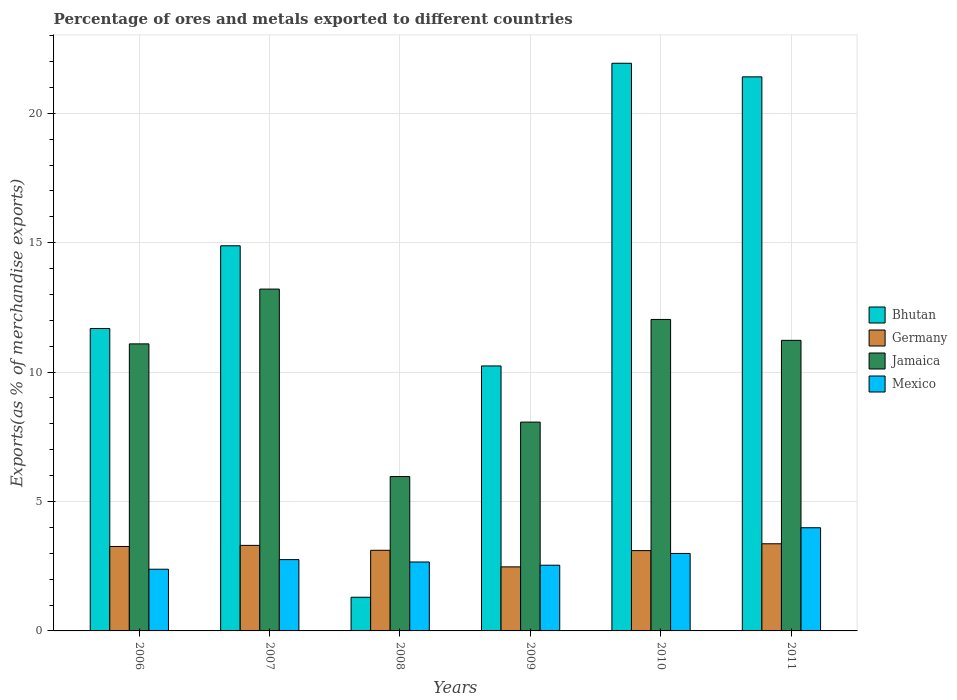How many different coloured bars are there?
Your answer should be very brief. 4. Are the number of bars per tick equal to the number of legend labels?
Your answer should be compact. Yes. How many bars are there on the 4th tick from the left?
Offer a terse response. 4. How many bars are there on the 4th tick from the right?
Your answer should be very brief. 4. What is the label of the 2nd group of bars from the left?
Provide a short and direct response. 2007. In how many cases, is the number of bars for a given year not equal to the number of legend labels?
Offer a very short reply. 0. What is the percentage of exports to different countries in Mexico in 2006?
Your answer should be compact. 2.38. Across all years, what is the maximum percentage of exports to different countries in Bhutan?
Offer a terse response. 21.93. Across all years, what is the minimum percentage of exports to different countries in Bhutan?
Give a very brief answer. 1.3. In which year was the percentage of exports to different countries in Mexico minimum?
Give a very brief answer. 2006. What is the total percentage of exports to different countries in Jamaica in the graph?
Offer a terse response. 61.59. What is the difference between the percentage of exports to different countries in Bhutan in 2006 and that in 2008?
Provide a succinct answer. 10.38. What is the difference between the percentage of exports to different countries in Bhutan in 2008 and the percentage of exports to different countries in Jamaica in 2009?
Your answer should be compact. -6.77. What is the average percentage of exports to different countries in Jamaica per year?
Ensure brevity in your answer.  10.27. In the year 2011, what is the difference between the percentage of exports to different countries in Jamaica and percentage of exports to different countries in Mexico?
Your answer should be compact. 7.24. In how many years, is the percentage of exports to different countries in Germany greater than 7 %?
Offer a very short reply. 0. What is the ratio of the percentage of exports to different countries in Mexico in 2007 to that in 2010?
Your response must be concise. 0.92. Is the difference between the percentage of exports to different countries in Jamaica in 2006 and 2011 greater than the difference between the percentage of exports to different countries in Mexico in 2006 and 2011?
Provide a short and direct response. Yes. What is the difference between the highest and the second highest percentage of exports to different countries in Mexico?
Give a very brief answer. 0.99. What is the difference between the highest and the lowest percentage of exports to different countries in Jamaica?
Keep it short and to the point. 7.24. In how many years, is the percentage of exports to different countries in Germany greater than the average percentage of exports to different countries in Germany taken over all years?
Your answer should be compact. 4. What does the 1st bar from the left in 2006 represents?
Ensure brevity in your answer.  Bhutan. What does the 4th bar from the right in 2008 represents?
Keep it short and to the point. Bhutan. How many years are there in the graph?
Make the answer very short. 6. What is the difference between two consecutive major ticks on the Y-axis?
Make the answer very short. 5. Are the values on the major ticks of Y-axis written in scientific E-notation?
Your response must be concise. No. Does the graph contain any zero values?
Your answer should be very brief. No. Does the graph contain grids?
Make the answer very short. Yes. How are the legend labels stacked?
Provide a succinct answer. Vertical. What is the title of the graph?
Provide a succinct answer. Percentage of ores and metals exported to different countries. What is the label or title of the Y-axis?
Offer a very short reply. Exports(as % of merchandise exports). What is the Exports(as % of merchandise exports) in Bhutan in 2006?
Give a very brief answer. 11.68. What is the Exports(as % of merchandise exports) in Germany in 2006?
Provide a succinct answer. 3.26. What is the Exports(as % of merchandise exports) in Jamaica in 2006?
Offer a very short reply. 11.09. What is the Exports(as % of merchandise exports) of Mexico in 2006?
Offer a very short reply. 2.38. What is the Exports(as % of merchandise exports) in Bhutan in 2007?
Keep it short and to the point. 14.88. What is the Exports(as % of merchandise exports) of Germany in 2007?
Give a very brief answer. 3.3. What is the Exports(as % of merchandise exports) in Jamaica in 2007?
Provide a short and direct response. 13.21. What is the Exports(as % of merchandise exports) of Mexico in 2007?
Your answer should be compact. 2.76. What is the Exports(as % of merchandise exports) in Bhutan in 2008?
Offer a very short reply. 1.3. What is the Exports(as % of merchandise exports) in Germany in 2008?
Make the answer very short. 3.12. What is the Exports(as % of merchandise exports) of Jamaica in 2008?
Ensure brevity in your answer.  5.96. What is the Exports(as % of merchandise exports) in Mexico in 2008?
Keep it short and to the point. 2.66. What is the Exports(as % of merchandise exports) in Bhutan in 2009?
Give a very brief answer. 10.24. What is the Exports(as % of merchandise exports) of Germany in 2009?
Offer a terse response. 2.48. What is the Exports(as % of merchandise exports) of Jamaica in 2009?
Make the answer very short. 8.07. What is the Exports(as % of merchandise exports) of Mexico in 2009?
Keep it short and to the point. 2.54. What is the Exports(as % of merchandise exports) of Bhutan in 2010?
Ensure brevity in your answer.  21.93. What is the Exports(as % of merchandise exports) of Germany in 2010?
Offer a very short reply. 3.1. What is the Exports(as % of merchandise exports) of Jamaica in 2010?
Your answer should be very brief. 12.03. What is the Exports(as % of merchandise exports) of Mexico in 2010?
Make the answer very short. 2.99. What is the Exports(as % of merchandise exports) of Bhutan in 2011?
Your answer should be compact. 21.41. What is the Exports(as % of merchandise exports) of Germany in 2011?
Make the answer very short. 3.37. What is the Exports(as % of merchandise exports) of Jamaica in 2011?
Ensure brevity in your answer.  11.23. What is the Exports(as % of merchandise exports) in Mexico in 2011?
Offer a very short reply. 3.99. Across all years, what is the maximum Exports(as % of merchandise exports) in Bhutan?
Your answer should be compact. 21.93. Across all years, what is the maximum Exports(as % of merchandise exports) of Germany?
Keep it short and to the point. 3.37. Across all years, what is the maximum Exports(as % of merchandise exports) of Jamaica?
Offer a terse response. 13.21. Across all years, what is the maximum Exports(as % of merchandise exports) of Mexico?
Provide a short and direct response. 3.99. Across all years, what is the minimum Exports(as % of merchandise exports) in Bhutan?
Your answer should be compact. 1.3. Across all years, what is the minimum Exports(as % of merchandise exports) in Germany?
Make the answer very short. 2.48. Across all years, what is the minimum Exports(as % of merchandise exports) in Jamaica?
Keep it short and to the point. 5.96. Across all years, what is the minimum Exports(as % of merchandise exports) in Mexico?
Keep it short and to the point. 2.38. What is the total Exports(as % of merchandise exports) in Bhutan in the graph?
Provide a short and direct response. 81.45. What is the total Exports(as % of merchandise exports) of Germany in the graph?
Make the answer very short. 18.63. What is the total Exports(as % of merchandise exports) of Jamaica in the graph?
Provide a short and direct response. 61.59. What is the total Exports(as % of merchandise exports) of Mexico in the graph?
Provide a succinct answer. 17.32. What is the difference between the Exports(as % of merchandise exports) in Bhutan in 2006 and that in 2007?
Give a very brief answer. -3.2. What is the difference between the Exports(as % of merchandise exports) of Germany in 2006 and that in 2007?
Give a very brief answer. -0.04. What is the difference between the Exports(as % of merchandise exports) in Jamaica in 2006 and that in 2007?
Keep it short and to the point. -2.12. What is the difference between the Exports(as % of merchandise exports) of Mexico in 2006 and that in 2007?
Offer a terse response. -0.37. What is the difference between the Exports(as % of merchandise exports) in Bhutan in 2006 and that in 2008?
Provide a short and direct response. 10.38. What is the difference between the Exports(as % of merchandise exports) in Germany in 2006 and that in 2008?
Your answer should be very brief. 0.15. What is the difference between the Exports(as % of merchandise exports) in Jamaica in 2006 and that in 2008?
Ensure brevity in your answer.  5.13. What is the difference between the Exports(as % of merchandise exports) of Mexico in 2006 and that in 2008?
Make the answer very short. -0.28. What is the difference between the Exports(as % of merchandise exports) of Bhutan in 2006 and that in 2009?
Your response must be concise. 1.45. What is the difference between the Exports(as % of merchandise exports) in Germany in 2006 and that in 2009?
Make the answer very short. 0.79. What is the difference between the Exports(as % of merchandise exports) in Jamaica in 2006 and that in 2009?
Provide a succinct answer. 3.02. What is the difference between the Exports(as % of merchandise exports) in Mexico in 2006 and that in 2009?
Make the answer very short. -0.16. What is the difference between the Exports(as % of merchandise exports) of Bhutan in 2006 and that in 2010?
Ensure brevity in your answer.  -10.25. What is the difference between the Exports(as % of merchandise exports) of Germany in 2006 and that in 2010?
Your response must be concise. 0.16. What is the difference between the Exports(as % of merchandise exports) in Jamaica in 2006 and that in 2010?
Offer a very short reply. -0.94. What is the difference between the Exports(as % of merchandise exports) of Mexico in 2006 and that in 2010?
Provide a short and direct response. -0.61. What is the difference between the Exports(as % of merchandise exports) of Bhutan in 2006 and that in 2011?
Make the answer very short. -9.73. What is the difference between the Exports(as % of merchandise exports) of Germany in 2006 and that in 2011?
Your response must be concise. -0.1. What is the difference between the Exports(as % of merchandise exports) of Jamaica in 2006 and that in 2011?
Your answer should be compact. -0.14. What is the difference between the Exports(as % of merchandise exports) in Mexico in 2006 and that in 2011?
Your response must be concise. -1.6. What is the difference between the Exports(as % of merchandise exports) of Bhutan in 2007 and that in 2008?
Provide a short and direct response. 13.58. What is the difference between the Exports(as % of merchandise exports) in Germany in 2007 and that in 2008?
Provide a succinct answer. 0.19. What is the difference between the Exports(as % of merchandise exports) in Jamaica in 2007 and that in 2008?
Your answer should be compact. 7.24. What is the difference between the Exports(as % of merchandise exports) in Mexico in 2007 and that in 2008?
Offer a terse response. 0.09. What is the difference between the Exports(as % of merchandise exports) of Bhutan in 2007 and that in 2009?
Provide a short and direct response. 4.64. What is the difference between the Exports(as % of merchandise exports) of Germany in 2007 and that in 2009?
Provide a succinct answer. 0.83. What is the difference between the Exports(as % of merchandise exports) in Jamaica in 2007 and that in 2009?
Ensure brevity in your answer.  5.14. What is the difference between the Exports(as % of merchandise exports) of Mexico in 2007 and that in 2009?
Keep it short and to the point. 0.22. What is the difference between the Exports(as % of merchandise exports) of Bhutan in 2007 and that in 2010?
Your response must be concise. -7.05. What is the difference between the Exports(as % of merchandise exports) in Germany in 2007 and that in 2010?
Ensure brevity in your answer.  0.2. What is the difference between the Exports(as % of merchandise exports) in Jamaica in 2007 and that in 2010?
Give a very brief answer. 1.17. What is the difference between the Exports(as % of merchandise exports) in Mexico in 2007 and that in 2010?
Provide a short and direct response. -0.24. What is the difference between the Exports(as % of merchandise exports) of Bhutan in 2007 and that in 2011?
Your answer should be very brief. -6.53. What is the difference between the Exports(as % of merchandise exports) of Germany in 2007 and that in 2011?
Keep it short and to the point. -0.06. What is the difference between the Exports(as % of merchandise exports) of Jamaica in 2007 and that in 2011?
Give a very brief answer. 1.98. What is the difference between the Exports(as % of merchandise exports) in Mexico in 2007 and that in 2011?
Your response must be concise. -1.23. What is the difference between the Exports(as % of merchandise exports) of Bhutan in 2008 and that in 2009?
Give a very brief answer. -8.94. What is the difference between the Exports(as % of merchandise exports) in Germany in 2008 and that in 2009?
Your response must be concise. 0.64. What is the difference between the Exports(as % of merchandise exports) of Jamaica in 2008 and that in 2009?
Provide a short and direct response. -2.1. What is the difference between the Exports(as % of merchandise exports) in Mexico in 2008 and that in 2009?
Make the answer very short. 0.12. What is the difference between the Exports(as % of merchandise exports) in Bhutan in 2008 and that in 2010?
Give a very brief answer. -20.63. What is the difference between the Exports(as % of merchandise exports) in Germany in 2008 and that in 2010?
Keep it short and to the point. 0.01. What is the difference between the Exports(as % of merchandise exports) of Jamaica in 2008 and that in 2010?
Ensure brevity in your answer.  -6.07. What is the difference between the Exports(as % of merchandise exports) of Mexico in 2008 and that in 2010?
Give a very brief answer. -0.33. What is the difference between the Exports(as % of merchandise exports) in Bhutan in 2008 and that in 2011?
Keep it short and to the point. -20.11. What is the difference between the Exports(as % of merchandise exports) in Germany in 2008 and that in 2011?
Your answer should be compact. -0.25. What is the difference between the Exports(as % of merchandise exports) in Jamaica in 2008 and that in 2011?
Your answer should be very brief. -5.26. What is the difference between the Exports(as % of merchandise exports) of Mexico in 2008 and that in 2011?
Provide a short and direct response. -1.32. What is the difference between the Exports(as % of merchandise exports) in Bhutan in 2009 and that in 2010?
Your answer should be very brief. -11.7. What is the difference between the Exports(as % of merchandise exports) of Germany in 2009 and that in 2010?
Your answer should be very brief. -0.63. What is the difference between the Exports(as % of merchandise exports) in Jamaica in 2009 and that in 2010?
Ensure brevity in your answer.  -3.97. What is the difference between the Exports(as % of merchandise exports) in Mexico in 2009 and that in 2010?
Give a very brief answer. -0.45. What is the difference between the Exports(as % of merchandise exports) in Bhutan in 2009 and that in 2011?
Your response must be concise. -11.17. What is the difference between the Exports(as % of merchandise exports) in Germany in 2009 and that in 2011?
Your answer should be compact. -0.89. What is the difference between the Exports(as % of merchandise exports) of Jamaica in 2009 and that in 2011?
Your answer should be compact. -3.16. What is the difference between the Exports(as % of merchandise exports) in Mexico in 2009 and that in 2011?
Your answer should be compact. -1.45. What is the difference between the Exports(as % of merchandise exports) in Bhutan in 2010 and that in 2011?
Give a very brief answer. 0.53. What is the difference between the Exports(as % of merchandise exports) in Germany in 2010 and that in 2011?
Ensure brevity in your answer.  -0.26. What is the difference between the Exports(as % of merchandise exports) in Jamaica in 2010 and that in 2011?
Offer a very short reply. 0.81. What is the difference between the Exports(as % of merchandise exports) of Mexico in 2010 and that in 2011?
Provide a short and direct response. -0.99. What is the difference between the Exports(as % of merchandise exports) of Bhutan in 2006 and the Exports(as % of merchandise exports) of Germany in 2007?
Your answer should be very brief. 8.38. What is the difference between the Exports(as % of merchandise exports) in Bhutan in 2006 and the Exports(as % of merchandise exports) in Jamaica in 2007?
Offer a very short reply. -1.52. What is the difference between the Exports(as % of merchandise exports) of Bhutan in 2006 and the Exports(as % of merchandise exports) of Mexico in 2007?
Make the answer very short. 8.93. What is the difference between the Exports(as % of merchandise exports) in Germany in 2006 and the Exports(as % of merchandise exports) in Jamaica in 2007?
Keep it short and to the point. -9.95. What is the difference between the Exports(as % of merchandise exports) in Germany in 2006 and the Exports(as % of merchandise exports) in Mexico in 2007?
Offer a very short reply. 0.51. What is the difference between the Exports(as % of merchandise exports) of Jamaica in 2006 and the Exports(as % of merchandise exports) of Mexico in 2007?
Your answer should be compact. 8.34. What is the difference between the Exports(as % of merchandise exports) in Bhutan in 2006 and the Exports(as % of merchandise exports) in Germany in 2008?
Your answer should be very brief. 8.57. What is the difference between the Exports(as % of merchandise exports) in Bhutan in 2006 and the Exports(as % of merchandise exports) in Jamaica in 2008?
Keep it short and to the point. 5.72. What is the difference between the Exports(as % of merchandise exports) in Bhutan in 2006 and the Exports(as % of merchandise exports) in Mexico in 2008?
Offer a terse response. 9.02. What is the difference between the Exports(as % of merchandise exports) of Germany in 2006 and the Exports(as % of merchandise exports) of Jamaica in 2008?
Provide a short and direct response. -2.7. What is the difference between the Exports(as % of merchandise exports) in Germany in 2006 and the Exports(as % of merchandise exports) in Mexico in 2008?
Your answer should be very brief. 0.6. What is the difference between the Exports(as % of merchandise exports) in Jamaica in 2006 and the Exports(as % of merchandise exports) in Mexico in 2008?
Provide a short and direct response. 8.43. What is the difference between the Exports(as % of merchandise exports) in Bhutan in 2006 and the Exports(as % of merchandise exports) in Germany in 2009?
Keep it short and to the point. 9.21. What is the difference between the Exports(as % of merchandise exports) in Bhutan in 2006 and the Exports(as % of merchandise exports) in Jamaica in 2009?
Provide a succinct answer. 3.61. What is the difference between the Exports(as % of merchandise exports) of Bhutan in 2006 and the Exports(as % of merchandise exports) of Mexico in 2009?
Your answer should be very brief. 9.14. What is the difference between the Exports(as % of merchandise exports) in Germany in 2006 and the Exports(as % of merchandise exports) in Jamaica in 2009?
Your answer should be compact. -4.81. What is the difference between the Exports(as % of merchandise exports) of Germany in 2006 and the Exports(as % of merchandise exports) of Mexico in 2009?
Give a very brief answer. 0.72. What is the difference between the Exports(as % of merchandise exports) of Jamaica in 2006 and the Exports(as % of merchandise exports) of Mexico in 2009?
Give a very brief answer. 8.55. What is the difference between the Exports(as % of merchandise exports) of Bhutan in 2006 and the Exports(as % of merchandise exports) of Germany in 2010?
Provide a short and direct response. 8.58. What is the difference between the Exports(as % of merchandise exports) in Bhutan in 2006 and the Exports(as % of merchandise exports) in Jamaica in 2010?
Give a very brief answer. -0.35. What is the difference between the Exports(as % of merchandise exports) of Bhutan in 2006 and the Exports(as % of merchandise exports) of Mexico in 2010?
Your response must be concise. 8.69. What is the difference between the Exports(as % of merchandise exports) of Germany in 2006 and the Exports(as % of merchandise exports) of Jamaica in 2010?
Your response must be concise. -8.77. What is the difference between the Exports(as % of merchandise exports) in Germany in 2006 and the Exports(as % of merchandise exports) in Mexico in 2010?
Offer a terse response. 0.27. What is the difference between the Exports(as % of merchandise exports) in Jamaica in 2006 and the Exports(as % of merchandise exports) in Mexico in 2010?
Keep it short and to the point. 8.1. What is the difference between the Exports(as % of merchandise exports) of Bhutan in 2006 and the Exports(as % of merchandise exports) of Germany in 2011?
Ensure brevity in your answer.  8.32. What is the difference between the Exports(as % of merchandise exports) of Bhutan in 2006 and the Exports(as % of merchandise exports) of Jamaica in 2011?
Offer a terse response. 0.46. What is the difference between the Exports(as % of merchandise exports) in Bhutan in 2006 and the Exports(as % of merchandise exports) in Mexico in 2011?
Offer a very short reply. 7.7. What is the difference between the Exports(as % of merchandise exports) of Germany in 2006 and the Exports(as % of merchandise exports) of Jamaica in 2011?
Keep it short and to the point. -7.96. What is the difference between the Exports(as % of merchandise exports) in Germany in 2006 and the Exports(as % of merchandise exports) in Mexico in 2011?
Make the answer very short. -0.72. What is the difference between the Exports(as % of merchandise exports) in Jamaica in 2006 and the Exports(as % of merchandise exports) in Mexico in 2011?
Offer a very short reply. 7.1. What is the difference between the Exports(as % of merchandise exports) in Bhutan in 2007 and the Exports(as % of merchandise exports) in Germany in 2008?
Give a very brief answer. 11.77. What is the difference between the Exports(as % of merchandise exports) of Bhutan in 2007 and the Exports(as % of merchandise exports) of Jamaica in 2008?
Offer a very short reply. 8.92. What is the difference between the Exports(as % of merchandise exports) of Bhutan in 2007 and the Exports(as % of merchandise exports) of Mexico in 2008?
Give a very brief answer. 12.22. What is the difference between the Exports(as % of merchandise exports) in Germany in 2007 and the Exports(as % of merchandise exports) in Jamaica in 2008?
Offer a terse response. -2.66. What is the difference between the Exports(as % of merchandise exports) of Germany in 2007 and the Exports(as % of merchandise exports) of Mexico in 2008?
Give a very brief answer. 0.64. What is the difference between the Exports(as % of merchandise exports) of Jamaica in 2007 and the Exports(as % of merchandise exports) of Mexico in 2008?
Give a very brief answer. 10.54. What is the difference between the Exports(as % of merchandise exports) of Bhutan in 2007 and the Exports(as % of merchandise exports) of Germany in 2009?
Your answer should be compact. 12.41. What is the difference between the Exports(as % of merchandise exports) of Bhutan in 2007 and the Exports(as % of merchandise exports) of Jamaica in 2009?
Make the answer very short. 6.81. What is the difference between the Exports(as % of merchandise exports) in Bhutan in 2007 and the Exports(as % of merchandise exports) in Mexico in 2009?
Your response must be concise. 12.34. What is the difference between the Exports(as % of merchandise exports) of Germany in 2007 and the Exports(as % of merchandise exports) of Jamaica in 2009?
Provide a short and direct response. -4.76. What is the difference between the Exports(as % of merchandise exports) in Germany in 2007 and the Exports(as % of merchandise exports) in Mexico in 2009?
Ensure brevity in your answer.  0.77. What is the difference between the Exports(as % of merchandise exports) in Jamaica in 2007 and the Exports(as % of merchandise exports) in Mexico in 2009?
Provide a short and direct response. 10.67. What is the difference between the Exports(as % of merchandise exports) in Bhutan in 2007 and the Exports(as % of merchandise exports) in Germany in 2010?
Provide a short and direct response. 11.78. What is the difference between the Exports(as % of merchandise exports) in Bhutan in 2007 and the Exports(as % of merchandise exports) in Jamaica in 2010?
Your answer should be very brief. 2.85. What is the difference between the Exports(as % of merchandise exports) of Bhutan in 2007 and the Exports(as % of merchandise exports) of Mexico in 2010?
Your answer should be compact. 11.89. What is the difference between the Exports(as % of merchandise exports) in Germany in 2007 and the Exports(as % of merchandise exports) in Jamaica in 2010?
Your response must be concise. -8.73. What is the difference between the Exports(as % of merchandise exports) in Germany in 2007 and the Exports(as % of merchandise exports) in Mexico in 2010?
Keep it short and to the point. 0.31. What is the difference between the Exports(as % of merchandise exports) of Jamaica in 2007 and the Exports(as % of merchandise exports) of Mexico in 2010?
Give a very brief answer. 10.21. What is the difference between the Exports(as % of merchandise exports) of Bhutan in 2007 and the Exports(as % of merchandise exports) of Germany in 2011?
Offer a very short reply. 11.51. What is the difference between the Exports(as % of merchandise exports) of Bhutan in 2007 and the Exports(as % of merchandise exports) of Jamaica in 2011?
Your response must be concise. 3.65. What is the difference between the Exports(as % of merchandise exports) of Bhutan in 2007 and the Exports(as % of merchandise exports) of Mexico in 2011?
Your answer should be very brief. 10.89. What is the difference between the Exports(as % of merchandise exports) of Germany in 2007 and the Exports(as % of merchandise exports) of Jamaica in 2011?
Offer a very short reply. -7.92. What is the difference between the Exports(as % of merchandise exports) in Germany in 2007 and the Exports(as % of merchandise exports) in Mexico in 2011?
Ensure brevity in your answer.  -0.68. What is the difference between the Exports(as % of merchandise exports) of Jamaica in 2007 and the Exports(as % of merchandise exports) of Mexico in 2011?
Ensure brevity in your answer.  9.22. What is the difference between the Exports(as % of merchandise exports) of Bhutan in 2008 and the Exports(as % of merchandise exports) of Germany in 2009?
Your response must be concise. -1.17. What is the difference between the Exports(as % of merchandise exports) of Bhutan in 2008 and the Exports(as % of merchandise exports) of Jamaica in 2009?
Offer a terse response. -6.77. What is the difference between the Exports(as % of merchandise exports) of Bhutan in 2008 and the Exports(as % of merchandise exports) of Mexico in 2009?
Your answer should be compact. -1.24. What is the difference between the Exports(as % of merchandise exports) in Germany in 2008 and the Exports(as % of merchandise exports) in Jamaica in 2009?
Provide a succinct answer. -4.95. What is the difference between the Exports(as % of merchandise exports) in Germany in 2008 and the Exports(as % of merchandise exports) in Mexico in 2009?
Your answer should be very brief. 0.58. What is the difference between the Exports(as % of merchandise exports) of Jamaica in 2008 and the Exports(as % of merchandise exports) of Mexico in 2009?
Give a very brief answer. 3.43. What is the difference between the Exports(as % of merchandise exports) of Bhutan in 2008 and the Exports(as % of merchandise exports) of Germany in 2010?
Offer a very short reply. -1.8. What is the difference between the Exports(as % of merchandise exports) of Bhutan in 2008 and the Exports(as % of merchandise exports) of Jamaica in 2010?
Give a very brief answer. -10.73. What is the difference between the Exports(as % of merchandise exports) of Bhutan in 2008 and the Exports(as % of merchandise exports) of Mexico in 2010?
Give a very brief answer. -1.69. What is the difference between the Exports(as % of merchandise exports) in Germany in 2008 and the Exports(as % of merchandise exports) in Jamaica in 2010?
Your answer should be very brief. -8.92. What is the difference between the Exports(as % of merchandise exports) in Germany in 2008 and the Exports(as % of merchandise exports) in Mexico in 2010?
Ensure brevity in your answer.  0.12. What is the difference between the Exports(as % of merchandise exports) of Jamaica in 2008 and the Exports(as % of merchandise exports) of Mexico in 2010?
Provide a short and direct response. 2.97. What is the difference between the Exports(as % of merchandise exports) of Bhutan in 2008 and the Exports(as % of merchandise exports) of Germany in 2011?
Ensure brevity in your answer.  -2.07. What is the difference between the Exports(as % of merchandise exports) in Bhutan in 2008 and the Exports(as % of merchandise exports) in Jamaica in 2011?
Your answer should be compact. -9.93. What is the difference between the Exports(as % of merchandise exports) of Bhutan in 2008 and the Exports(as % of merchandise exports) of Mexico in 2011?
Ensure brevity in your answer.  -2.69. What is the difference between the Exports(as % of merchandise exports) in Germany in 2008 and the Exports(as % of merchandise exports) in Jamaica in 2011?
Make the answer very short. -8.11. What is the difference between the Exports(as % of merchandise exports) in Germany in 2008 and the Exports(as % of merchandise exports) in Mexico in 2011?
Give a very brief answer. -0.87. What is the difference between the Exports(as % of merchandise exports) of Jamaica in 2008 and the Exports(as % of merchandise exports) of Mexico in 2011?
Provide a succinct answer. 1.98. What is the difference between the Exports(as % of merchandise exports) of Bhutan in 2009 and the Exports(as % of merchandise exports) of Germany in 2010?
Make the answer very short. 7.14. What is the difference between the Exports(as % of merchandise exports) of Bhutan in 2009 and the Exports(as % of merchandise exports) of Jamaica in 2010?
Keep it short and to the point. -1.8. What is the difference between the Exports(as % of merchandise exports) of Bhutan in 2009 and the Exports(as % of merchandise exports) of Mexico in 2010?
Ensure brevity in your answer.  7.25. What is the difference between the Exports(as % of merchandise exports) of Germany in 2009 and the Exports(as % of merchandise exports) of Jamaica in 2010?
Provide a succinct answer. -9.56. What is the difference between the Exports(as % of merchandise exports) in Germany in 2009 and the Exports(as % of merchandise exports) in Mexico in 2010?
Your answer should be compact. -0.52. What is the difference between the Exports(as % of merchandise exports) in Jamaica in 2009 and the Exports(as % of merchandise exports) in Mexico in 2010?
Keep it short and to the point. 5.08. What is the difference between the Exports(as % of merchandise exports) in Bhutan in 2009 and the Exports(as % of merchandise exports) in Germany in 2011?
Offer a very short reply. 6.87. What is the difference between the Exports(as % of merchandise exports) of Bhutan in 2009 and the Exports(as % of merchandise exports) of Jamaica in 2011?
Your answer should be very brief. -0.99. What is the difference between the Exports(as % of merchandise exports) in Bhutan in 2009 and the Exports(as % of merchandise exports) in Mexico in 2011?
Offer a very short reply. 6.25. What is the difference between the Exports(as % of merchandise exports) in Germany in 2009 and the Exports(as % of merchandise exports) in Jamaica in 2011?
Provide a succinct answer. -8.75. What is the difference between the Exports(as % of merchandise exports) of Germany in 2009 and the Exports(as % of merchandise exports) of Mexico in 2011?
Your answer should be compact. -1.51. What is the difference between the Exports(as % of merchandise exports) of Jamaica in 2009 and the Exports(as % of merchandise exports) of Mexico in 2011?
Your answer should be compact. 4.08. What is the difference between the Exports(as % of merchandise exports) in Bhutan in 2010 and the Exports(as % of merchandise exports) in Germany in 2011?
Ensure brevity in your answer.  18.57. What is the difference between the Exports(as % of merchandise exports) of Bhutan in 2010 and the Exports(as % of merchandise exports) of Jamaica in 2011?
Offer a very short reply. 10.71. What is the difference between the Exports(as % of merchandise exports) in Bhutan in 2010 and the Exports(as % of merchandise exports) in Mexico in 2011?
Provide a short and direct response. 17.95. What is the difference between the Exports(as % of merchandise exports) in Germany in 2010 and the Exports(as % of merchandise exports) in Jamaica in 2011?
Keep it short and to the point. -8.12. What is the difference between the Exports(as % of merchandise exports) of Germany in 2010 and the Exports(as % of merchandise exports) of Mexico in 2011?
Provide a short and direct response. -0.88. What is the difference between the Exports(as % of merchandise exports) in Jamaica in 2010 and the Exports(as % of merchandise exports) in Mexico in 2011?
Keep it short and to the point. 8.05. What is the average Exports(as % of merchandise exports) of Bhutan per year?
Ensure brevity in your answer.  13.57. What is the average Exports(as % of merchandise exports) in Germany per year?
Provide a short and direct response. 3.1. What is the average Exports(as % of merchandise exports) of Jamaica per year?
Give a very brief answer. 10.27. What is the average Exports(as % of merchandise exports) of Mexico per year?
Your answer should be very brief. 2.89. In the year 2006, what is the difference between the Exports(as % of merchandise exports) of Bhutan and Exports(as % of merchandise exports) of Germany?
Ensure brevity in your answer.  8.42. In the year 2006, what is the difference between the Exports(as % of merchandise exports) of Bhutan and Exports(as % of merchandise exports) of Jamaica?
Give a very brief answer. 0.59. In the year 2006, what is the difference between the Exports(as % of merchandise exports) of Bhutan and Exports(as % of merchandise exports) of Mexico?
Your response must be concise. 9.3. In the year 2006, what is the difference between the Exports(as % of merchandise exports) of Germany and Exports(as % of merchandise exports) of Jamaica?
Your response must be concise. -7.83. In the year 2006, what is the difference between the Exports(as % of merchandise exports) of Germany and Exports(as % of merchandise exports) of Mexico?
Keep it short and to the point. 0.88. In the year 2006, what is the difference between the Exports(as % of merchandise exports) of Jamaica and Exports(as % of merchandise exports) of Mexico?
Provide a short and direct response. 8.71. In the year 2007, what is the difference between the Exports(as % of merchandise exports) of Bhutan and Exports(as % of merchandise exports) of Germany?
Your answer should be compact. 11.58. In the year 2007, what is the difference between the Exports(as % of merchandise exports) in Bhutan and Exports(as % of merchandise exports) in Jamaica?
Your answer should be compact. 1.67. In the year 2007, what is the difference between the Exports(as % of merchandise exports) of Bhutan and Exports(as % of merchandise exports) of Mexico?
Offer a terse response. 12.13. In the year 2007, what is the difference between the Exports(as % of merchandise exports) in Germany and Exports(as % of merchandise exports) in Jamaica?
Provide a short and direct response. -9.9. In the year 2007, what is the difference between the Exports(as % of merchandise exports) in Germany and Exports(as % of merchandise exports) in Mexico?
Ensure brevity in your answer.  0.55. In the year 2007, what is the difference between the Exports(as % of merchandise exports) in Jamaica and Exports(as % of merchandise exports) in Mexico?
Offer a very short reply. 10.45. In the year 2008, what is the difference between the Exports(as % of merchandise exports) in Bhutan and Exports(as % of merchandise exports) in Germany?
Keep it short and to the point. -1.81. In the year 2008, what is the difference between the Exports(as % of merchandise exports) of Bhutan and Exports(as % of merchandise exports) of Jamaica?
Your answer should be very brief. -4.66. In the year 2008, what is the difference between the Exports(as % of merchandise exports) of Bhutan and Exports(as % of merchandise exports) of Mexico?
Make the answer very short. -1.36. In the year 2008, what is the difference between the Exports(as % of merchandise exports) in Germany and Exports(as % of merchandise exports) in Jamaica?
Your answer should be compact. -2.85. In the year 2008, what is the difference between the Exports(as % of merchandise exports) of Germany and Exports(as % of merchandise exports) of Mexico?
Your response must be concise. 0.45. In the year 2008, what is the difference between the Exports(as % of merchandise exports) in Jamaica and Exports(as % of merchandise exports) in Mexico?
Offer a very short reply. 3.3. In the year 2009, what is the difference between the Exports(as % of merchandise exports) of Bhutan and Exports(as % of merchandise exports) of Germany?
Offer a very short reply. 7.76. In the year 2009, what is the difference between the Exports(as % of merchandise exports) in Bhutan and Exports(as % of merchandise exports) in Jamaica?
Your response must be concise. 2.17. In the year 2009, what is the difference between the Exports(as % of merchandise exports) of Bhutan and Exports(as % of merchandise exports) of Mexico?
Give a very brief answer. 7.7. In the year 2009, what is the difference between the Exports(as % of merchandise exports) of Germany and Exports(as % of merchandise exports) of Jamaica?
Offer a very short reply. -5.59. In the year 2009, what is the difference between the Exports(as % of merchandise exports) in Germany and Exports(as % of merchandise exports) in Mexico?
Keep it short and to the point. -0.06. In the year 2009, what is the difference between the Exports(as % of merchandise exports) of Jamaica and Exports(as % of merchandise exports) of Mexico?
Your answer should be compact. 5.53. In the year 2010, what is the difference between the Exports(as % of merchandise exports) in Bhutan and Exports(as % of merchandise exports) in Germany?
Provide a short and direct response. 18.83. In the year 2010, what is the difference between the Exports(as % of merchandise exports) of Bhutan and Exports(as % of merchandise exports) of Jamaica?
Offer a terse response. 9.9. In the year 2010, what is the difference between the Exports(as % of merchandise exports) in Bhutan and Exports(as % of merchandise exports) in Mexico?
Your answer should be compact. 18.94. In the year 2010, what is the difference between the Exports(as % of merchandise exports) in Germany and Exports(as % of merchandise exports) in Jamaica?
Your answer should be compact. -8.93. In the year 2010, what is the difference between the Exports(as % of merchandise exports) of Germany and Exports(as % of merchandise exports) of Mexico?
Provide a short and direct response. 0.11. In the year 2010, what is the difference between the Exports(as % of merchandise exports) of Jamaica and Exports(as % of merchandise exports) of Mexico?
Give a very brief answer. 9.04. In the year 2011, what is the difference between the Exports(as % of merchandise exports) of Bhutan and Exports(as % of merchandise exports) of Germany?
Your answer should be very brief. 18.04. In the year 2011, what is the difference between the Exports(as % of merchandise exports) of Bhutan and Exports(as % of merchandise exports) of Jamaica?
Your answer should be compact. 10.18. In the year 2011, what is the difference between the Exports(as % of merchandise exports) in Bhutan and Exports(as % of merchandise exports) in Mexico?
Your answer should be very brief. 17.42. In the year 2011, what is the difference between the Exports(as % of merchandise exports) of Germany and Exports(as % of merchandise exports) of Jamaica?
Your response must be concise. -7.86. In the year 2011, what is the difference between the Exports(as % of merchandise exports) in Germany and Exports(as % of merchandise exports) in Mexico?
Your response must be concise. -0.62. In the year 2011, what is the difference between the Exports(as % of merchandise exports) of Jamaica and Exports(as % of merchandise exports) of Mexico?
Make the answer very short. 7.24. What is the ratio of the Exports(as % of merchandise exports) of Bhutan in 2006 to that in 2007?
Keep it short and to the point. 0.79. What is the ratio of the Exports(as % of merchandise exports) of Germany in 2006 to that in 2007?
Make the answer very short. 0.99. What is the ratio of the Exports(as % of merchandise exports) in Jamaica in 2006 to that in 2007?
Your response must be concise. 0.84. What is the ratio of the Exports(as % of merchandise exports) of Mexico in 2006 to that in 2007?
Offer a terse response. 0.86. What is the ratio of the Exports(as % of merchandise exports) in Bhutan in 2006 to that in 2008?
Make the answer very short. 8.98. What is the ratio of the Exports(as % of merchandise exports) of Germany in 2006 to that in 2008?
Keep it short and to the point. 1.05. What is the ratio of the Exports(as % of merchandise exports) of Jamaica in 2006 to that in 2008?
Give a very brief answer. 1.86. What is the ratio of the Exports(as % of merchandise exports) of Mexico in 2006 to that in 2008?
Offer a terse response. 0.89. What is the ratio of the Exports(as % of merchandise exports) in Bhutan in 2006 to that in 2009?
Your response must be concise. 1.14. What is the ratio of the Exports(as % of merchandise exports) in Germany in 2006 to that in 2009?
Keep it short and to the point. 1.32. What is the ratio of the Exports(as % of merchandise exports) in Jamaica in 2006 to that in 2009?
Provide a short and direct response. 1.37. What is the ratio of the Exports(as % of merchandise exports) of Mexico in 2006 to that in 2009?
Give a very brief answer. 0.94. What is the ratio of the Exports(as % of merchandise exports) in Bhutan in 2006 to that in 2010?
Your answer should be compact. 0.53. What is the ratio of the Exports(as % of merchandise exports) of Germany in 2006 to that in 2010?
Provide a short and direct response. 1.05. What is the ratio of the Exports(as % of merchandise exports) of Jamaica in 2006 to that in 2010?
Provide a succinct answer. 0.92. What is the ratio of the Exports(as % of merchandise exports) of Mexico in 2006 to that in 2010?
Provide a short and direct response. 0.8. What is the ratio of the Exports(as % of merchandise exports) in Bhutan in 2006 to that in 2011?
Provide a succinct answer. 0.55. What is the ratio of the Exports(as % of merchandise exports) of Jamaica in 2006 to that in 2011?
Provide a short and direct response. 0.99. What is the ratio of the Exports(as % of merchandise exports) of Mexico in 2006 to that in 2011?
Offer a very short reply. 0.6. What is the ratio of the Exports(as % of merchandise exports) of Bhutan in 2007 to that in 2008?
Give a very brief answer. 11.43. What is the ratio of the Exports(as % of merchandise exports) of Germany in 2007 to that in 2008?
Provide a short and direct response. 1.06. What is the ratio of the Exports(as % of merchandise exports) in Jamaica in 2007 to that in 2008?
Your answer should be compact. 2.21. What is the ratio of the Exports(as % of merchandise exports) of Mexico in 2007 to that in 2008?
Make the answer very short. 1.03. What is the ratio of the Exports(as % of merchandise exports) in Bhutan in 2007 to that in 2009?
Make the answer very short. 1.45. What is the ratio of the Exports(as % of merchandise exports) of Germany in 2007 to that in 2009?
Your answer should be compact. 1.34. What is the ratio of the Exports(as % of merchandise exports) of Jamaica in 2007 to that in 2009?
Your response must be concise. 1.64. What is the ratio of the Exports(as % of merchandise exports) of Mexico in 2007 to that in 2009?
Ensure brevity in your answer.  1.09. What is the ratio of the Exports(as % of merchandise exports) of Bhutan in 2007 to that in 2010?
Provide a succinct answer. 0.68. What is the ratio of the Exports(as % of merchandise exports) of Germany in 2007 to that in 2010?
Give a very brief answer. 1.06. What is the ratio of the Exports(as % of merchandise exports) in Jamaica in 2007 to that in 2010?
Your answer should be compact. 1.1. What is the ratio of the Exports(as % of merchandise exports) in Mexico in 2007 to that in 2010?
Give a very brief answer. 0.92. What is the ratio of the Exports(as % of merchandise exports) in Bhutan in 2007 to that in 2011?
Make the answer very short. 0.7. What is the ratio of the Exports(as % of merchandise exports) of Germany in 2007 to that in 2011?
Provide a short and direct response. 0.98. What is the ratio of the Exports(as % of merchandise exports) in Jamaica in 2007 to that in 2011?
Make the answer very short. 1.18. What is the ratio of the Exports(as % of merchandise exports) of Mexico in 2007 to that in 2011?
Provide a succinct answer. 0.69. What is the ratio of the Exports(as % of merchandise exports) in Bhutan in 2008 to that in 2009?
Your answer should be very brief. 0.13. What is the ratio of the Exports(as % of merchandise exports) of Germany in 2008 to that in 2009?
Your answer should be very brief. 1.26. What is the ratio of the Exports(as % of merchandise exports) in Jamaica in 2008 to that in 2009?
Keep it short and to the point. 0.74. What is the ratio of the Exports(as % of merchandise exports) in Mexico in 2008 to that in 2009?
Offer a terse response. 1.05. What is the ratio of the Exports(as % of merchandise exports) in Bhutan in 2008 to that in 2010?
Offer a terse response. 0.06. What is the ratio of the Exports(as % of merchandise exports) in Jamaica in 2008 to that in 2010?
Provide a short and direct response. 0.5. What is the ratio of the Exports(as % of merchandise exports) in Mexico in 2008 to that in 2010?
Your answer should be compact. 0.89. What is the ratio of the Exports(as % of merchandise exports) in Bhutan in 2008 to that in 2011?
Ensure brevity in your answer.  0.06. What is the ratio of the Exports(as % of merchandise exports) in Germany in 2008 to that in 2011?
Offer a terse response. 0.93. What is the ratio of the Exports(as % of merchandise exports) in Jamaica in 2008 to that in 2011?
Your answer should be compact. 0.53. What is the ratio of the Exports(as % of merchandise exports) of Mexico in 2008 to that in 2011?
Keep it short and to the point. 0.67. What is the ratio of the Exports(as % of merchandise exports) in Bhutan in 2009 to that in 2010?
Make the answer very short. 0.47. What is the ratio of the Exports(as % of merchandise exports) of Germany in 2009 to that in 2010?
Offer a very short reply. 0.8. What is the ratio of the Exports(as % of merchandise exports) of Jamaica in 2009 to that in 2010?
Provide a short and direct response. 0.67. What is the ratio of the Exports(as % of merchandise exports) of Mexico in 2009 to that in 2010?
Give a very brief answer. 0.85. What is the ratio of the Exports(as % of merchandise exports) in Bhutan in 2009 to that in 2011?
Make the answer very short. 0.48. What is the ratio of the Exports(as % of merchandise exports) in Germany in 2009 to that in 2011?
Your answer should be compact. 0.74. What is the ratio of the Exports(as % of merchandise exports) of Jamaica in 2009 to that in 2011?
Provide a short and direct response. 0.72. What is the ratio of the Exports(as % of merchandise exports) in Mexico in 2009 to that in 2011?
Offer a terse response. 0.64. What is the ratio of the Exports(as % of merchandise exports) of Bhutan in 2010 to that in 2011?
Ensure brevity in your answer.  1.02. What is the ratio of the Exports(as % of merchandise exports) in Germany in 2010 to that in 2011?
Your answer should be very brief. 0.92. What is the ratio of the Exports(as % of merchandise exports) of Jamaica in 2010 to that in 2011?
Offer a very short reply. 1.07. What is the ratio of the Exports(as % of merchandise exports) of Mexico in 2010 to that in 2011?
Your response must be concise. 0.75. What is the difference between the highest and the second highest Exports(as % of merchandise exports) in Bhutan?
Your answer should be compact. 0.53. What is the difference between the highest and the second highest Exports(as % of merchandise exports) of Germany?
Provide a short and direct response. 0.06. What is the difference between the highest and the second highest Exports(as % of merchandise exports) in Jamaica?
Ensure brevity in your answer.  1.17. What is the difference between the highest and the lowest Exports(as % of merchandise exports) in Bhutan?
Your answer should be compact. 20.63. What is the difference between the highest and the lowest Exports(as % of merchandise exports) in Germany?
Offer a very short reply. 0.89. What is the difference between the highest and the lowest Exports(as % of merchandise exports) in Jamaica?
Offer a very short reply. 7.24. What is the difference between the highest and the lowest Exports(as % of merchandise exports) of Mexico?
Keep it short and to the point. 1.6. 